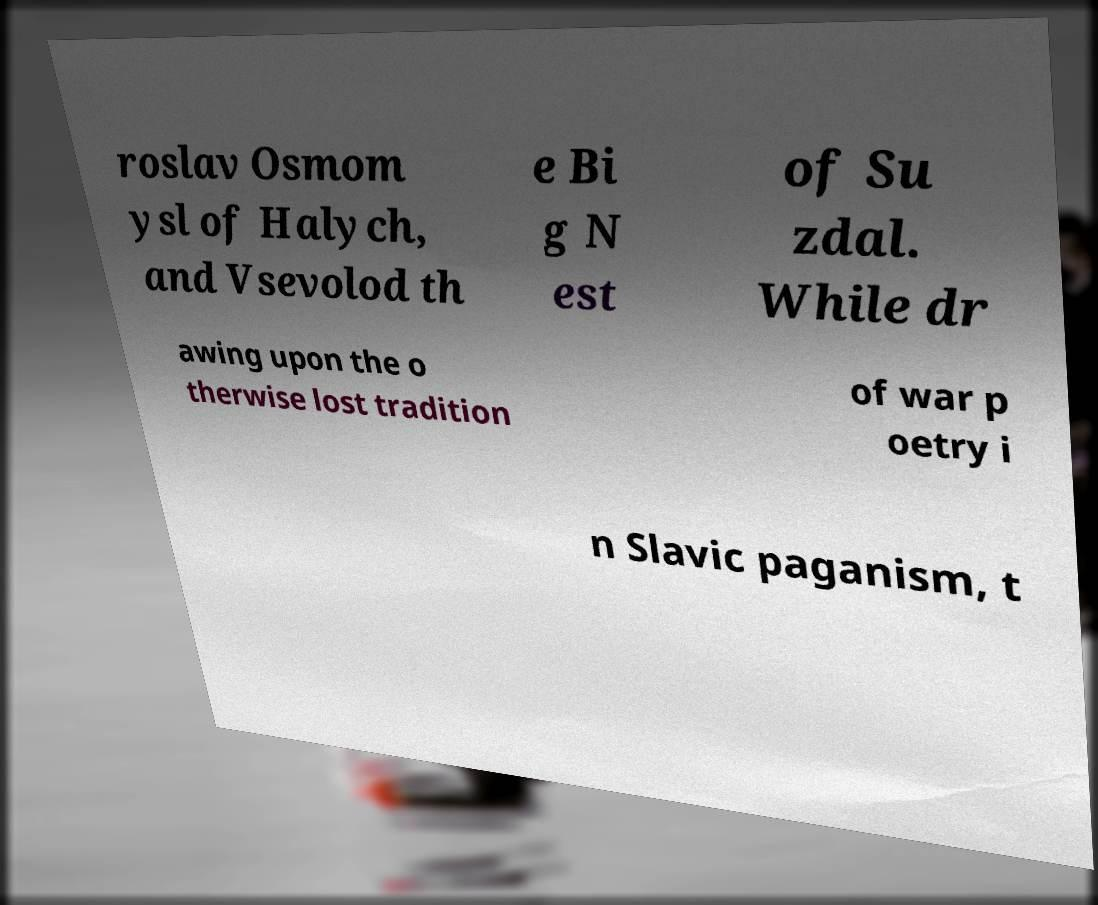Please read and relay the text visible in this image. What does it say? roslav Osmom ysl of Halych, and Vsevolod th e Bi g N est of Su zdal. While dr awing upon the o therwise lost tradition of war p oetry i n Slavic paganism, t 